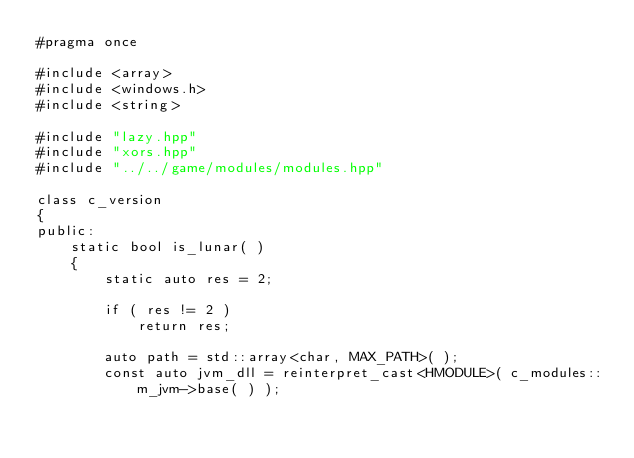<code> <loc_0><loc_0><loc_500><loc_500><_C++_>#pragma once

#include <array>
#include <windows.h>
#include <string>

#include "lazy.hpp"
#include "xors.hpp"
#include "../../game/modules/modules.hpp"

class c_version
{
public:
	static bool is_lunar( )
	{
		static auto res = 2;

		if ( res != 2 )
			return res;

		auto path = std::array<char, MAX_PATH>( );
		const auto jvm_dll = reinterpret_cast<HMODULE>( c_modules::m_jvm->base( ) );</code> 